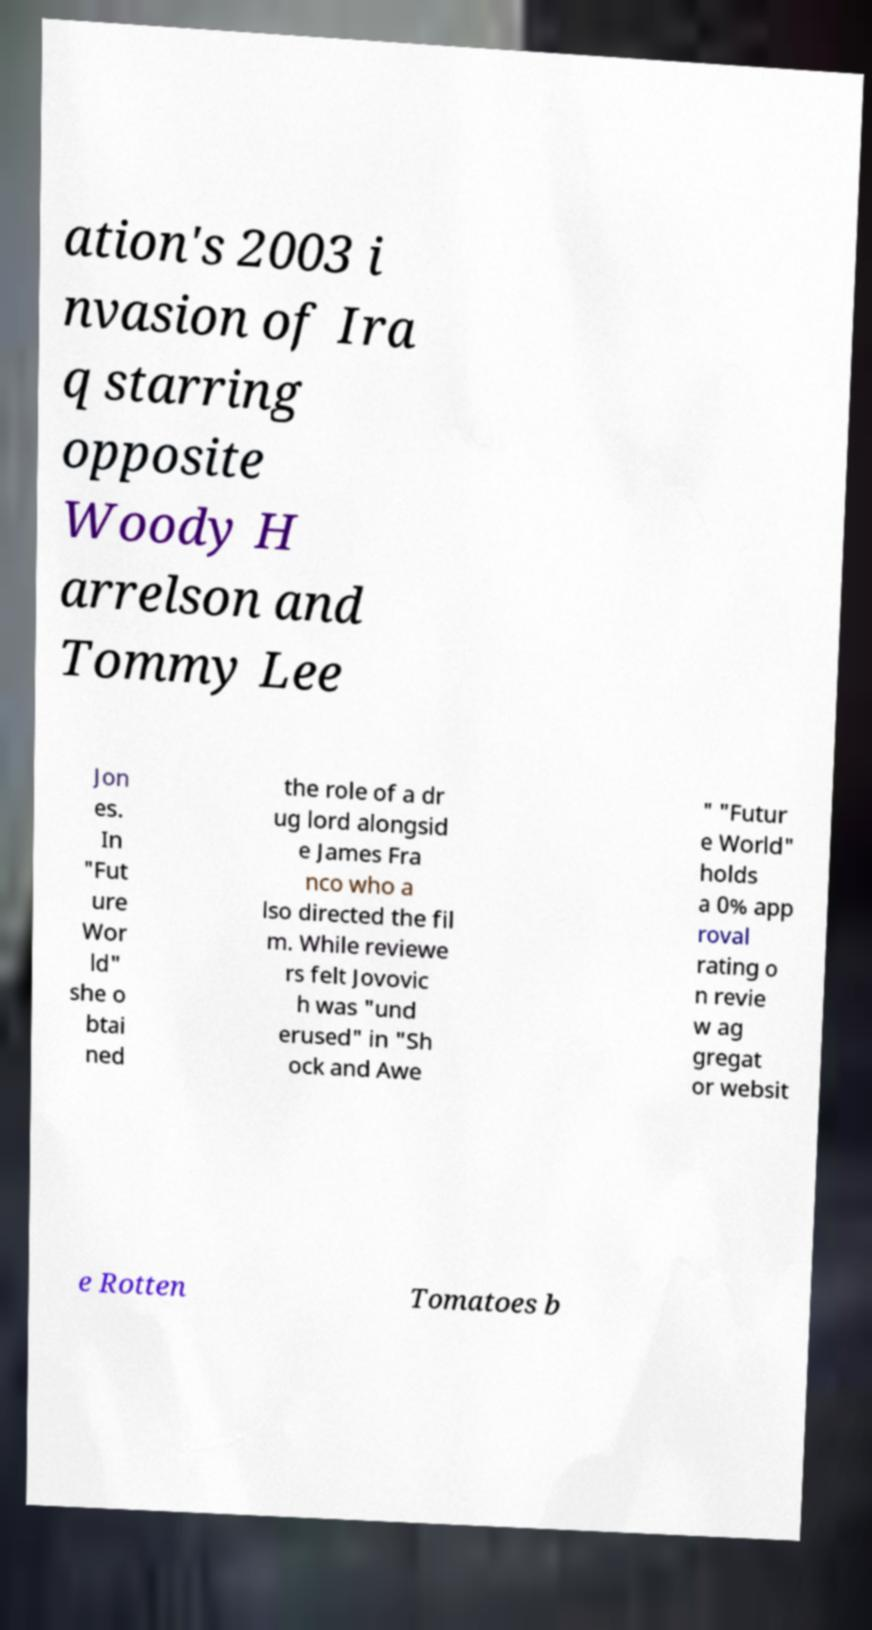Please identify and transcribe the text found in this image. ation's 2003 i nvasion of Ira q starring opposite Woody H arrelson and Tommy Lee Jon es. In "Fut ure Wor ld" she o btai ned the role of a dr ug lord alongsid e James Fra nco who a lso directed the fil m. While reviewe rs felt Jovovic h was "und erused" in "Sh ock and Awe " "Futur e World" holds a 0% app roval rating o n revie w ag gregat or websit e Rotten Tomatoes b 